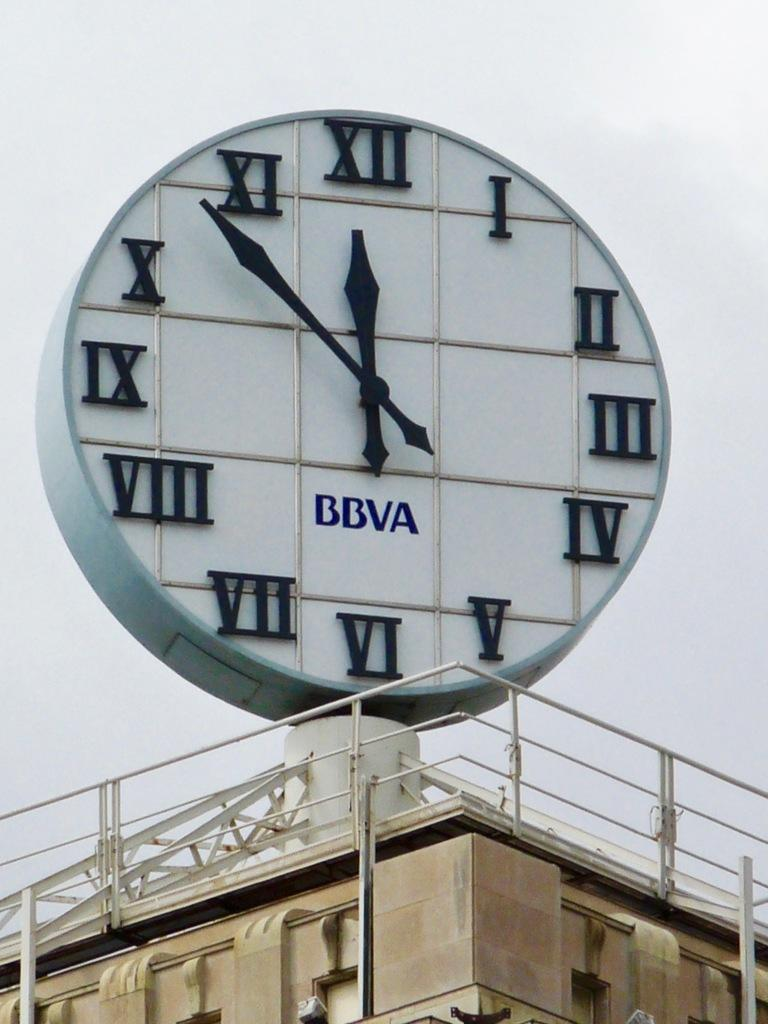<image>
Provide a brief description of the given image. The fours letters "BBVA" is printed across the middle of the clock. 